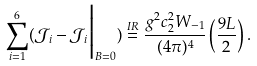Convert formula to latex. <formula><loc_0><loc_0><loc_500><loc_500>\sum _ { i = 1 } ^ { 6 } ( \mathcal { J } _ { i } - \mathcal { J } _ { i } \Big | _ { B = 0 } ) \stackrel { I R } { = } \frac { g ^ { 2 } c _ { 2 } ^ { 2 } W _ { - 1 } } { ( 4 \pi ) ^ { 4 } } \left ( \frac { 9 L } { 2 } \right ) .</formula> 